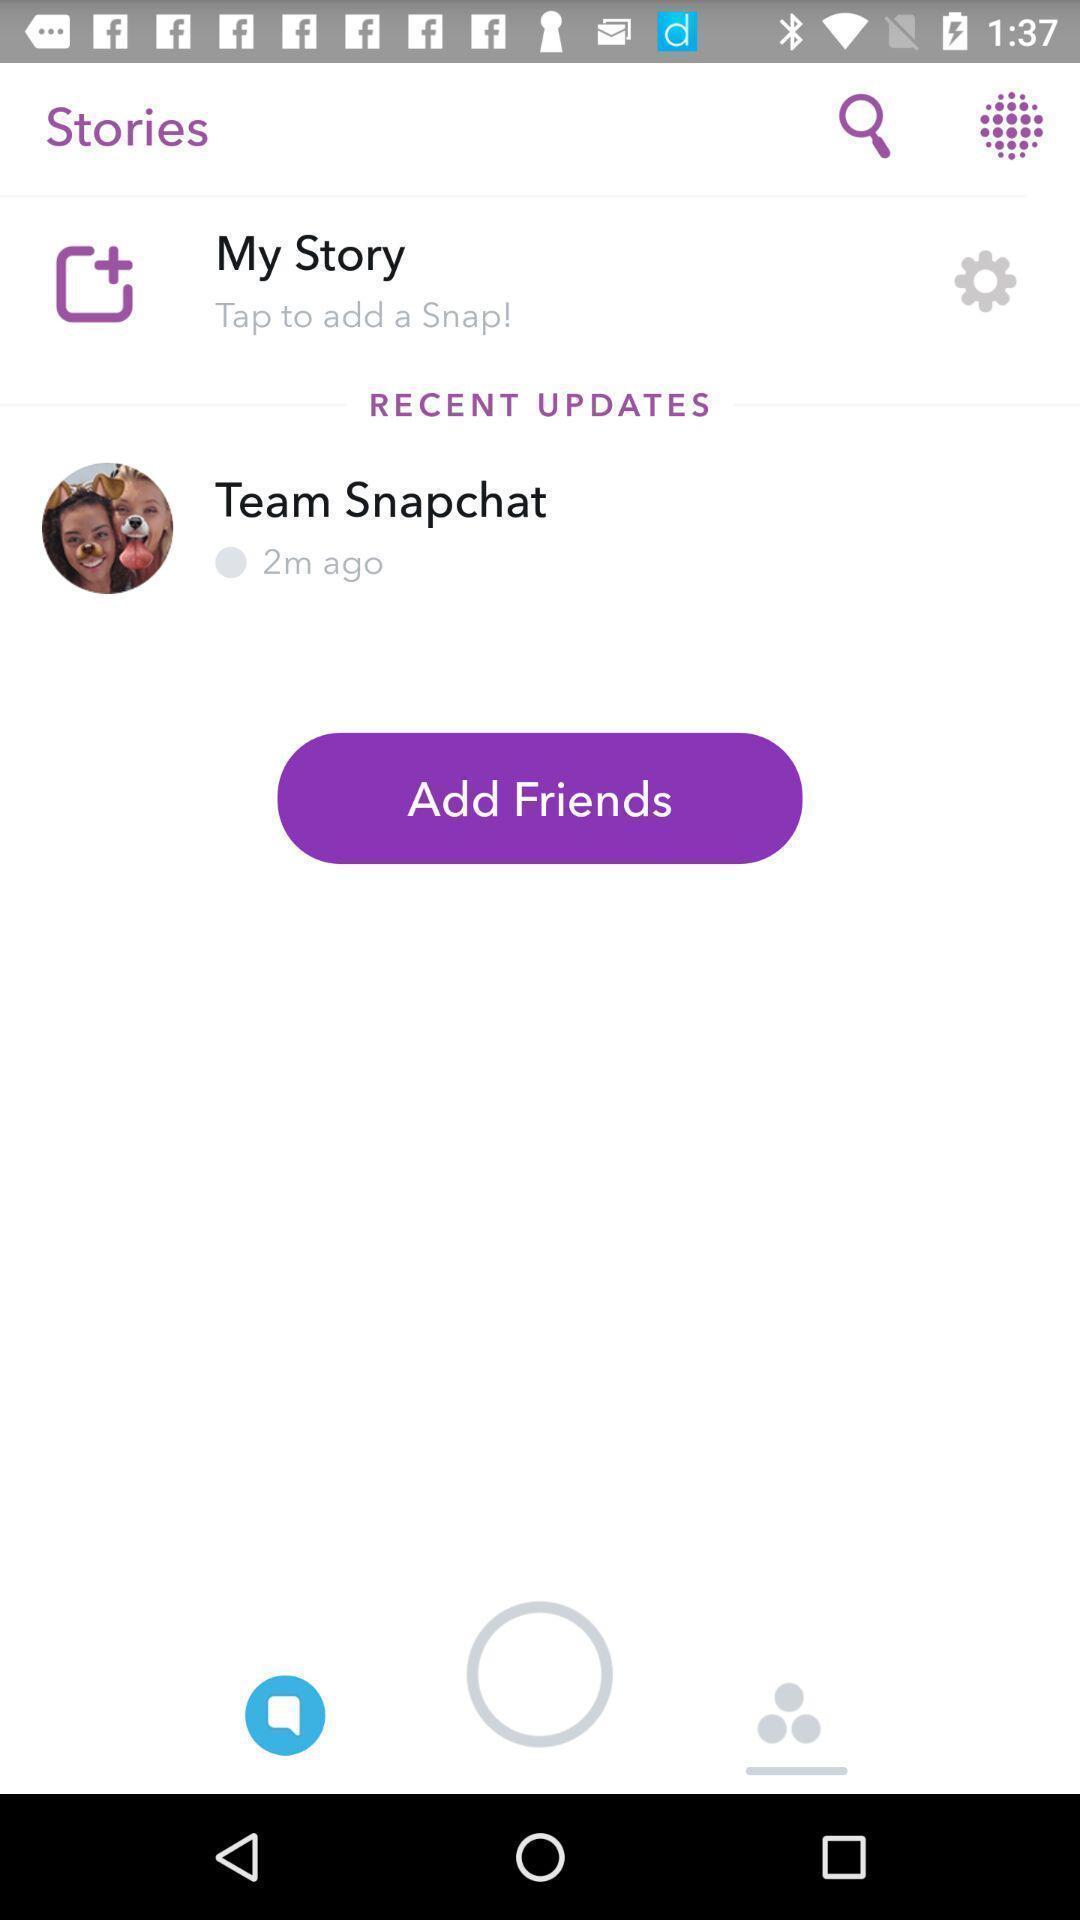Describe the visual elements of this screenshot. Profile page of a social app is displaying. 